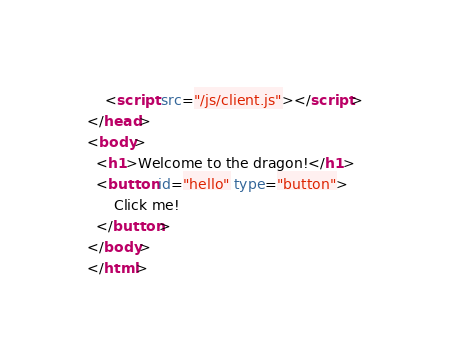Convert code to text. <code><loc_0><loc_0><loc_500><loc_500><_HTML_>    <script src="/js/client.js"></script>
</head>
<body>
  <h1>Welcome to the dragon!</h1>
  <button id="hello" type="button">
      Click me!
  </button>
</body>
</html></code> 